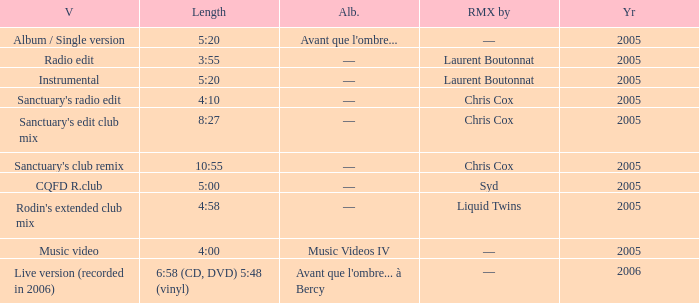What is the version shown for the Length of 5:20, and shows Remixed by —? Album / Single version. 